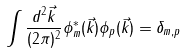<formula> <loc_0><loc_0><loc_500><loc_500>\int \frac { d ^ { 2 } \vec { k } } { ( 2 \pi ) ^ { 2 } } \phi ^ { * } _ { m } ( \vec { k } ) \phi _ { p } ( \vec { k } ) = \delta _ { m , p }</formula> 